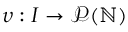<formula> <loc_0><loc_0><loc_500><loc_500>\upsilon \colon I \rightarrow \mathcal { P } ( \mathbb { N } )</formula> 